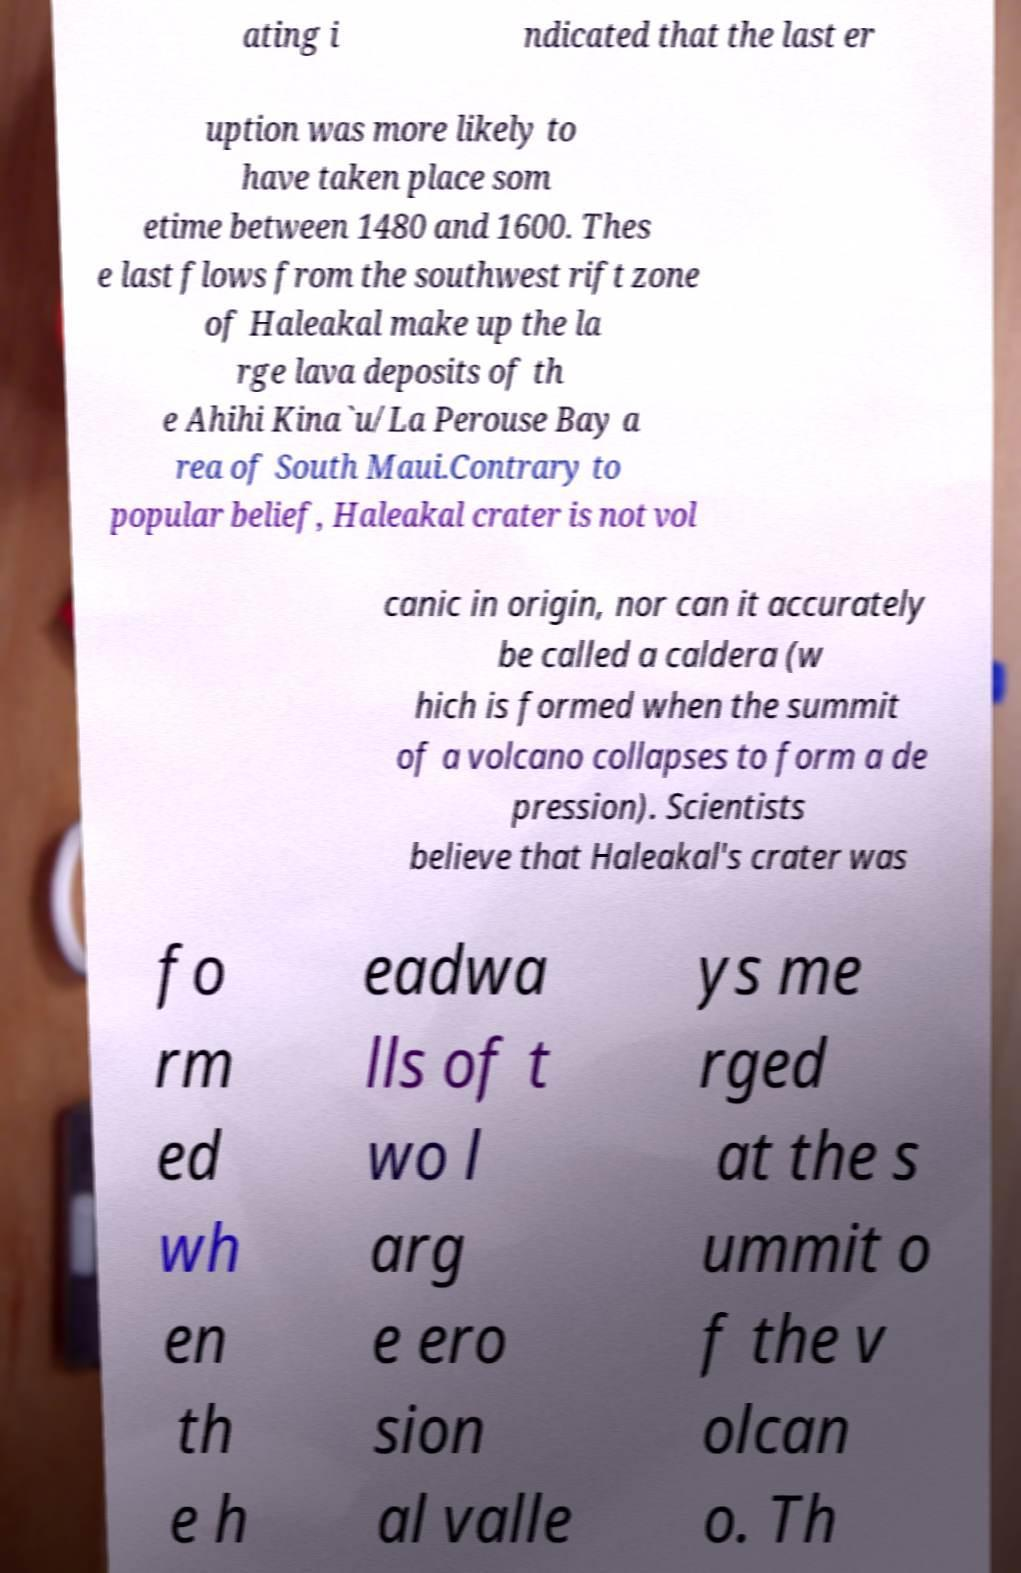Please read and relay the text visible in this image. What does it say? ating i ndicated that the last er uption was more likely to have taken place som etime between 1480 and 1600. Thes e last flows from the southwest rift zone of Haleakal make up the la rge lava deposits of th e Ahihi Kina`u/La Perouse Bay a rea of South Maui.Contrary to popular belief, Haleakal crater is not vol canic in origin, nor can it accurately be called a caldera (w hich is formed when the summit of a volcano collapses to form a de pression). Scientists believe that Haleakal's crater was fo rm ed wh en th e h eadwa lls of t wo l arg e ero sion al valle ys me rged at the s ummit o f the v olcan o. Th 